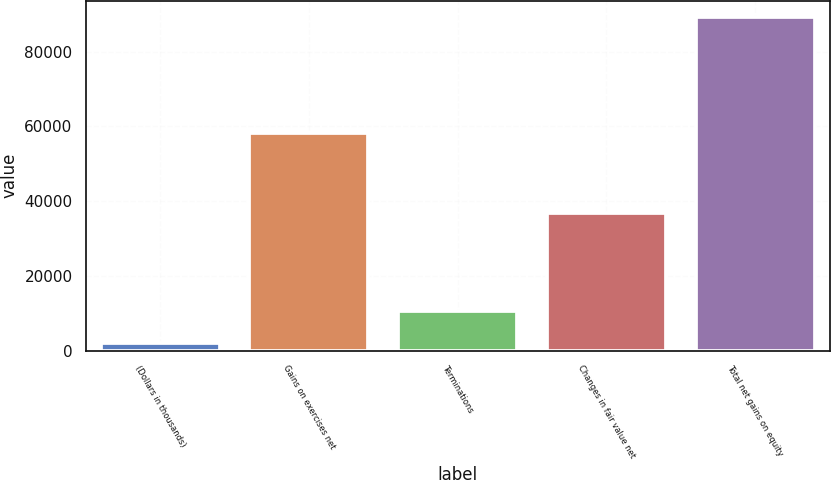Convert chart. <chart><loc_0><loc_0><loc_500><loc_500><bar_chart><fcel>(Dollars in thousands)<fcel>Gains on exercises net<fcel>Terminations<fcel>Changes in fair value net<fcel>Total net gains on equity<nl><fcel>2018<fcel>58186<fcel>10730.4<fcel>36920<fcel>89142<nl></chart> 